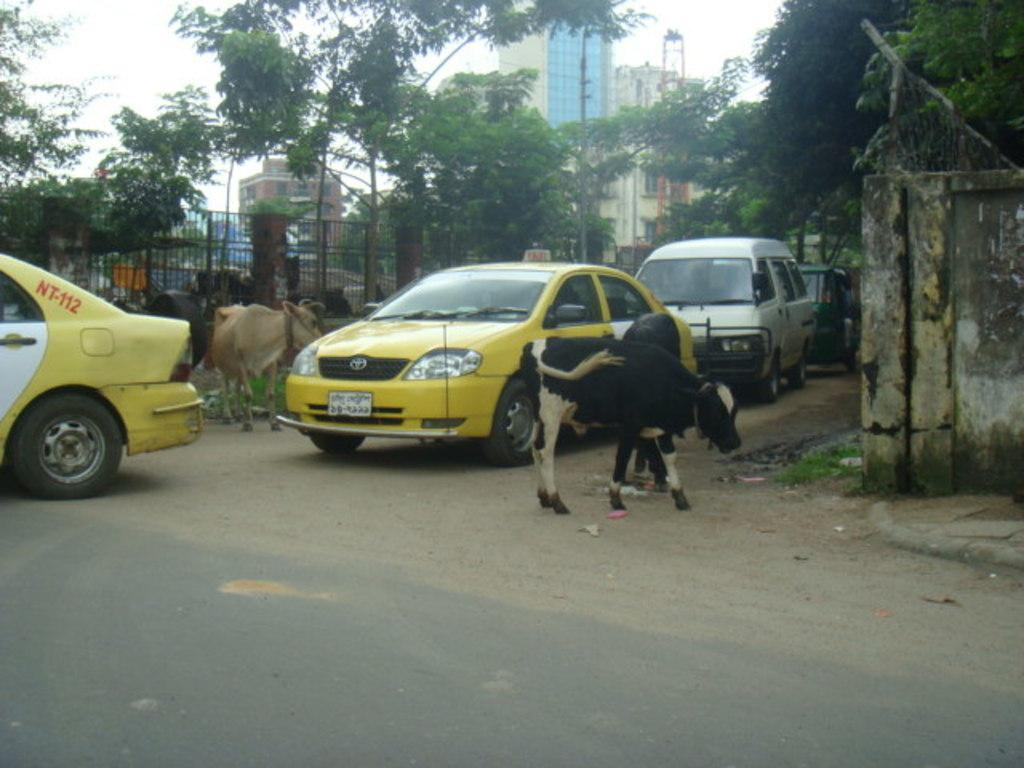Provide a one-sentence caption for the provided image. Several small calf's are on both sides of two taxi cabs, one marked as NT-112. 